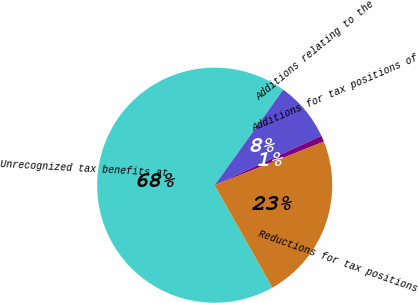<chart> <loc_0><loc_0><loc_500><loc_500><pie_chart><fcel>Unrecognized tax benefits at<fcel>Additions relating to the<fcel>Additions for tax positions of<fcel>Reductions for tax positions<nl><fcel>68.08%<fcel>8.19%<fcel>0.85%<fcel>22.88%<nl></chart> 